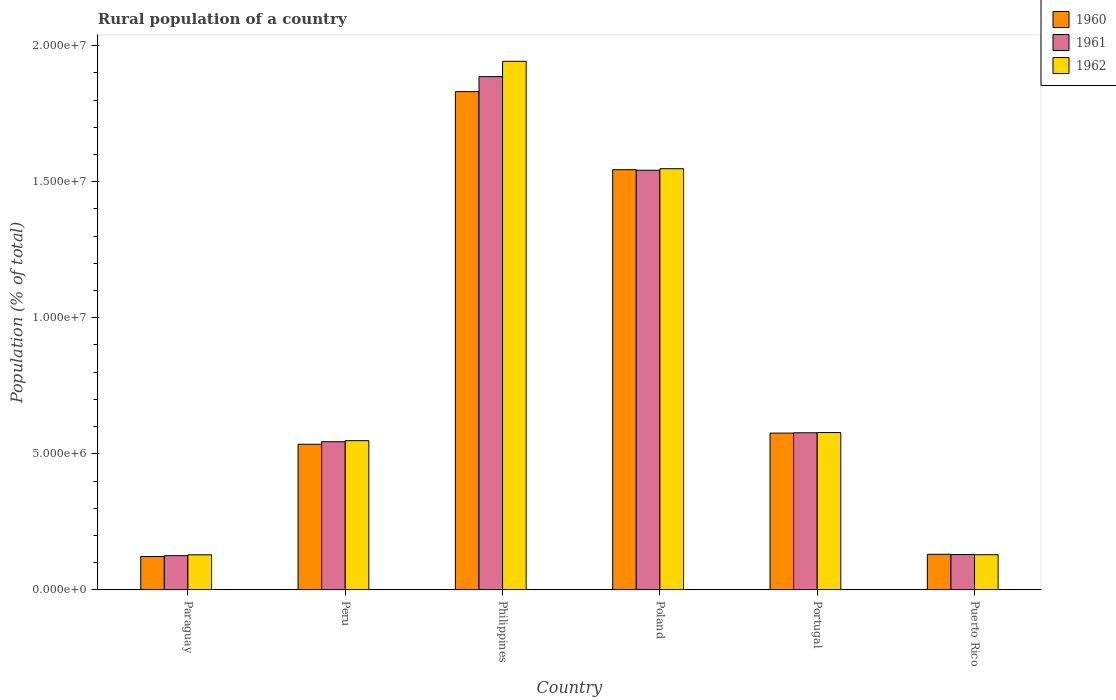How many different coloured bars are there?
Your answer should be compact. 3. How many groups of bars are there?
Your answer should be very brief. 6. What is the label of the 5th group of bars from the left?
Your answer should be very brief. Portugal. In how many cases, is the number of bars for a given country not equal to the number of legend labels?
Provide a succinct answer. 0. What is the rural population in 1961 in Paraguay?
Give a very brief answer. 1.26e+06. Across all countries, what is the maximum rural population in 1962?
Provide a short and direct response. 1.94e+07. Across all countries, what is the minimum rural population in 1960?
Your response must be concise. 1.23e+06. In which country was the rural population in 1961 maximum?
Provide a succinct answer. Philippines. In which country was the rural population in 1962 minimum?
Provide a short and direct response. Paraguay. What is the total rural population in 1962 in the graph?
Make the answer very short. 4.88e+07. What is the difference between the rural population in 1960 in Paraguay and that in Puerto Rico?
Provide a short and direct response. -8.15e+04. What is the difference between the rural population in 1961 in Philippines and the rural population in 1962 in Peru?
Your answer should be very brief. 1.34e+07. What is the average rural population in 1961 per country?
Your answer should be compact. 8.01e+06. What is the difference between the rural population of/in 1962 and rural population of/in 1960 in Philippines?
Provide a short and direct response. 1.11e+06. What is the ratio of the rural population in 1962 in Paraguay to that in Poland?
Offer a terse response. 0.08. Is the rural population in 1962 in Poland less than that in Puerto Rico?
Make the answer very short. No. Is the difference between the rural population in 1962 in Portugal and Puerto Rico greater than the difference between the rural population in 1960 in Portugal and Puerto Rico?
Ensure brevity in your answer.  Yes. What is the difference between the highest and the second highest rural population in 1960?
Provide a short and direct response. -9.68e+06. What is the difference between the highest and the lowest rural population in 1961?
Make the answer very short. 1.76e+07. In how many countries, is the rural population in 1961 greater than the average rural population in 1961 taken over all countries?
Your response must be concise. 2. Is the sum of the rural population in 1962 in Peru and Portugal greater than the maximum rural population in 1960 across all countries?
Your answer should be compact. No. What does the 2nd bar from the left in Paraguay represents?
Your answer should be very brief. 1961. Is it the case that in every country, the sum of the rural population in 1962 and rural population in 1961 is greater than the rural population in 1960?
Provide a succinct answer. Yes. How many bars are there?
Make the answer very short. 18. Are all the bars in the graph horizontal?
Keep it short and to the point. No. How many countries are there in the graph?
Your response must be concise. 6. What is the difference between two consecutive major ticks on the Y-axis?
Your response must be concise. 5.00e+06. Does the graph contain any zero values?
Your response must be concise. No. Does the graph contain grids?
Make the answer very short. No. How many legend labels are there?
Ensure brevity in your answer.  3. What is the title of the graph?
Your answer should be very brief. Rural population of a country. What is the label or title of the Y-axis?
Your answer should be very brief. Population (% of total). What is the Population (% of total) in 1960 in Paraguay?
Make the answer very short. 1.23e+06. What is the Population (% of total) of 1961 in Paraguay?
Offer a terse response. 1.26e+06. What is the Population (% of total) in 1962 in Paraguay?
Make the answer very short. 1.29e+06. What is the Population (% of total) in 1960 in Peru?
Ensure brevity in your answer.  5.35e+06. What is the Population (% of total) in 1961 in Peru?
Keep it short and to the point. 5.44e+06. What is the Population (% of total) of 1962 in Peru?
Give a very brief answer. 5.48e+06. What is the Population (% of total) of 1960 in Philippines?
Offer a terse response. 1.83e+07. What is the Population (% of total) in 1961 in Philippines?
Ensure brevity in your answer.  1.89e+07. What is the Population (% of total) in 1962 in Philippines?
Provide a succinct answer. 1.94e+07. What is the Population (% of total) of 1960 in Poland?
Make the answer very short. 1.54e+07. What is the Population (% of total) of 1961 in Poland?
Give a very brief answer. 1.54e+07. What is the Population (% of total) in 1962 in Poland?
Your answer should be compact. 1.55e+07. What is the Population (% of total) of 1960 in Portugal?
Your response must be concise. 5.76e+06. What is the Population (% of total) in 1961 in Portugal?
Provide a short and direct response. 5.77e+06. What is the Population (% of total) in 1962 in Portugal?
Give a very brief answer. 5.78e+06. What is the Population (% of total) of 1960 in Puerto Rico?
Your answer should be very brief. 1.31e+06. What is the Population (% of total) in 1961 in Puerto Rico?
Make the answer very short. 1.30e+06. What is the Population (% of total) in 1962 in Puerto Rico?
Give a very brief answer. 1.29e+06. Across all countries, what is the maximum Population (% of total) in 1960?
Your response must be concise. 1.83e+07. Across all countries, what is the maximum Population (% of total) in 1961?
Keep it short and to the point. 1.89e+07. Across all countries, what is the maximum Population (% of total) in 1962?
Provide a succinct answer. 1.94e+07. Across all countries, what is the minimum Population (% of total) in 1960?
Keep it short and to the point. 1.23e+06. Across all countries, what is the minimum Population (% of total) in 1961?
Keep it short and to the point. 1.26e+06. Across all countries, what is the minimum Population (% of total) in 1962?
Your response must be concise. 1.29e+06. What is the total Population (% of total) in 1960 in the graph?
Offer a terse response. 4.74e+07. What is the total Population (% of total) in 1961 in the graph?
Provide a succinct answer. 4.81e+07. What is the total Population (% of total) in 1962 in the graph?
Keep it short and to the point. 4.88e+07. What is the difference between the Population (% of total) of 1960 in Paraguay and that in Peru?
Give a very brief answer. -4.13e+06. What is the difference between the Population (% of total) of 1961 in Paraguay and that in Peru?
Your answer should be very brief. -4.19e+06. What is the difference between the Population (% of total) in 1962 in Paraguay and that in Peru?
Ensure brevity in your answer.  -4.20e+06. What is the difference between the Population (% of total) in 1960 in Paraguay and that in Philippines?
Offer a terse response. -1.71e+07. What is the difference between the Population (% of total) of 1961 in Paraguay and that in Philippines?
Give a very brief answer. -1.76e+07. What is the difference between the Population (% of total) in 1962 in Paraguay and that in Philippines?
Keep it short and to the point. -1.81e+07. What is the difference between the Population (% of total) in 1960 in Paraguay and that in Poland?
Keep it short and to the point. -1.42e+07. What is the difference between the Population (% of total) in 1961 in Paraguay and that in Poland?
Provide a succinct answer. -1.42e+07. What is the difference between the Population (% of total) of 1962 in Paraguay and that in Poland?
Your answer should be very brief. -1.42e+07. What is the difference between the Population (% of total) of 1960 in Paraguay and that in Portugal?
Ensure brevity in your answer.  -4.54e+06. What is the difference between the Population (% of total) in 1961 in Paraguay and that in Portugal?
Provide a short and direct response. -4.52e+06. What is the difference between the Population (% of total) in 1962 in Paraguay and that in Portugal?
Your answer should be compact. -4.49e+06. What is the difference between the Population (% of total) in 1960 in Paraguay and that in Puerto Rico?
Offer a terse response. -8.15e+04. What is the difference between the Population (% of total) of 1961 in Paraguay and that in Puerto Rico?
Make the answer very short. -4.09e+04. What is the difference between the Population (% of total) of 1962 in Paraguay and that in Puerto Rico?
Offer a terse response. -2650. What is the difference between the Population (% of total) of 1960 in Peru and that in Philippines?
Provide a short and direct response. -1.30e+07. What is the difference between the Population (% of total) of 1961 in Peru and that in Philippines?
Your answer should be compact. -1.34e+07. What is the difference between the Population (% of total) in 1962 in Peru and that in Philippines?
Ensure brevity in your answer.  -1.39e+07. What is the difference between the Population (% of total) in 1960 in Peru and that in Poland?
Offer a very short reply. -1.01e+07. What is the difference between the Population (% of total) of 1961 in Peru and that in Poland?
Give a very brief answer. -9.98e+06. What is the difference between the Population (% of total) in 1962 in Peru and that in Poland?
Provide a succinct answer. -1.00e+07. What is the difference between the Population (% of total) in 1960 in Peru and that in Portugal?
Your answer should be compact. -4.10e+05. What is the difference between the Population (% of total) in 1961 in Peru and that in Portugal?
Provide a succinct answer. -3.29e+05. What is the difference between the Population (% of total) in 1962 in Peru and that in Portugal?
Your answer should be compact. -2.98e+05. What is the difference between the Population (% of total) of 1960 in Peru and that in Puerto Rico?
Offer a very short reply. 4.04e+06. What is the difference between the Population (% of total) in 1961 in Peru and that in Puerto Rico?
Keep it short and to the point. 4.15e+06. What is the difference between the Population (% of total) of 1962 in Peru and that in Puerto Rico?
Provide a succinct answer. 4.19e+06. What is the difference between the Population (% of total) in 1960 in Philippines and that in Poland?
Ensure brevity in your answer.  2.87e+06. What is the difference between the Population (% of total) in 1961 in Philippines and that in Poland?
Your answer should be compact. 3.44e+06. What is the difference between the Population (% of total) in 1962 in Philippines and that in Poland?
Make the answer very short. 3.95e+06. What is the difference between the Population (% of total) in 1960 in Philippines and that in Portugal?
Your response must be concise. 1.26e+07. What is the difference between the Population (% of total) of 1961 in Philippines and that in Portugal?
Ensure brevity in your answer.  1.31e+07. What is the difference between the Population (% of total) in 1962 in Philippines and that in Portugal?
Keep it short and to the point. 1.36e+07. What is the difference between the Population (% of total) in 1960 in Philippines and that in Puerto Rico?
Make the answer very short. 1.70e+07. What is the difference between the Population (% of total) of 1961 in Philippines and that in Puerto Rico?
Your answer should be very brief. 1.76e+07. What is the difference between the Population (% of total) in 1962 in Philippines and that in Puerto Rico?
Give a very brief answer. 1.81e+07. What is the difference between the Population (% of total) of 1960 in Poland and that in Portugal?
Offer a very short reply. 9.68e+06. What is the difference between the Population (% of total) in 1961 in Poland and that in Portugal?
Make the answer very short. 9.65e+06. What is the difference between the Population (% of total) of 1962 in Poland and that in Portugal?
Make the answer very short. 9.70e+06. What is the difference between the Population (% of total) of 1960 in Poland and that in Puerto Rico?
Keep it short and to the point. 1.41e+07. What is the difference between the Population (% of total) of 1961 in Poland and that in Puerto Rico?
Provide a short and direct response. 1.41e+07. What is the difference between the Population (% of total) in 1962 in Poland and that in Puerto Rico?
Make the answer very short. 1.42e+07. What is the difference between the Population (% of total) in 1960 in Portugal and that in Puerto Rico?
Make the answer very short. 4.45e+06. What is the difference between the Population (% of total) in 1961 in Portugal and that in Puerto Rico?
Offer a very short reply. 4.48e+06. What is the difference between the Population (% of total) of 1962 in Portugal and that in Puerto Rico?
Keep it short and to the point. 4.49e+06. What is the difference between the Population (% of total) in 1960 in Paraguay and the Population (% of total) in 1961 in Peru?
Your answer should be compact. -4.22e+06. What is the difference between the Population (% of total) of 1960 in Paraguay and the Population (% of total) of 1962 in Peru?
Provide a succinct answer. -4.26e+06. What is the difference between the Population (% of total) in 1961 in Paraguay and the Population (% of total) in 1962 in Peru?
Offer a terse response. -4.23e+06. What is the difference between the Population (% of total) of 1960 in Paraguay and the Population (% of total) of 1961 in Philippines?
Your response must be concise. -1.76e+07. What is the difference between the Population (% of total) of 1960 in Paraguay and the Population (% of total) of 1962 in Philippines?
Keep it short and to the point. -1.82e+07. What is the difference between the Population (% of total) in 1961 in Paraguay and the Population (% of total) in 1962 in Philippines?
Your answer should be very brief. -1.82e+07. What is the difference between the Population (% of total) in 1960 in Paraguay and the Population (% of total) in 1961 in Poland?
Your response must be concise. -1.42e+07. What is the difference between the Population (% of total) of 1960 in Paraguay and the Population (% of total) of 1962 in Poland?
Your response must be concise. -1.43e+07. What is the difference between the Population (% of total) in 1961 in Paraguay and the Population (% of total) in 1962 in Poland?
Give a very brief answer. -1.42e+07. What is the difference between the Population (% of total) of 1960 in Paraguay and the Population (% of total) of 1961 in Portugal?
Your answer should be very brief. -4.55e+06. What is the difference between the Population (% of total) of 1960 in Paraguay and the Population (% of total) of 1962 in Portugal?
Your response must be concise. -4.56e+06. What is the difference between the Population (% of total) in 1961 in Paraguay and the Population (% of total) in 1962 in Portugal?
Offer a terse response. -4.52e+06. What is the difference between the Population (% of total) in 1960 in Paraguay and the Population (% of total) in 1961 in Puerto Rico?
Provide a succinct answer. -7.14e+04. What is the difference between the Population (% of total) in 1960 in Paraguay and the Population (% of total) in 1962 in Puerto Rico?
Your answer should be compact. -6.46e+04. What is the difference between the Population (% of total) of 1961 in Paraguay and the Population (% of total) of 1962 in Puerto Rico?
Give a very brief answer. -3.41e+04. What is the difference between the Population (% of total) in 1960 in Peru and the Population (% of total) in 1961 in Philippines?
Provide a short and direct response. -1.35e+07. What is the difference between the Population (% of total) in 1960 in Peru and the Population (% of total) in 1962 in Philippines?
Your answer should be very brief. -1.41e+07. What is the difference between the Population (% of total) of 1961 in Peru and the Population (% of total) of 1962 in Philippines?
Provide a succinct answer. -1.40e+07. What is the difference between the Population (% of total) in 1960 in Peru and the Population (% of total) in 1961 in Poland?
Your response must be concise. -1.01e+07. What is the difference between the Population (% of total) in 1960 in Peru and the Population (% of total) in 1962 in Poland?
Make the answer very short. -1.01e+07. What is the difference between the Population (% of total) of 1961 in Peru and the Population (% of total) of 1962 in Poland?
Your answer should be very brief. -1.00e+07. What is the difference between the Population (% of total) of 1960 in Peru and the Population (% of total) of 1961 in Portugal?
Make the answer very short. -4.22e+05. What is the difference between the Population (% of total) in 1960 in Peru and the Population (% of total) in 1962 in Portugal?
Your answer should be compact. -4.30e+05. What is the difference between the Population (% of total) of 1961 in Peru and the Population (% of total) of 1962 in Portugal?
Your answer should be very brief. -3.37e+05. What is the difference between the Population (% of total) in 1960 in Peru and the Population (% of total) in 1961 in Puerto Rico?
Offer a very short reply. 4.05e+06. What is the difference between the Population (% of total) of 1960 in Peru and the Population (% of total) of 1962 in Puerto Rico?
Make the answer very short. 4.06e+06. What is the difference between the Population (% of total) of 1961 in Peru and the Population (% of total) of 1962 in Puerto Rico?
Offer a very short reply. 4.15e+06. What is the difference between the Population (% of total) in 1960 in Philippines and the Population (% of total) in 1961 in Poland?
Offer a terse response. 2.89e+06. What is the difference between the Population (% of total) of 1960 in Philippines and the Population (% of total) of 1962 in Poland?
Your answer should be compact. 2.83e+06. What is the difference between the Population (% of total) in 1961 in Philippines and the Population (% of total) in 1962 in Poland?
Keep it short and to the point. 3.38e+06. What is the difference between the Population (% of total) in 1960 in Philippines and the Population (% of total) in 1961 in Portugal?
Offer a terse response. 1.25e+07. What is the difference between the Population (% of total) in 1960 in Philippines and the Population (% of total) in 1962 in Portugal?
Offer a terse response. 1.25e+07. What is the difference between the Population (% of total) of 1961 in Philippines and the Population (% of total) of 1962 in Portugal?
Your response must be concise. 1.31e+07. What is the difference between the Population (% of total) in 1960 in Philippines and the Population (% of total) in 1961 in Puerto Rico?
Keep it short and to the point. 1.70e+07. What is the difference between the Population (% of total) in 1960 in Philippines and the Population (% of total) in 1962 in Puerto Rico?
Offer a very short reply. 1.70e+07. What is the difference between the Population (% of total) of 1961 in Philippines and the Population (% of total) of 1962 in Puerto Rico?
Keep it short and to the point. 1.76e+07. What is the difference between the Population (% of total) of 1960 in Poland and the Population (% of total) of 1961 in Portugal?
Your answer should be very brief. 9.67e+06. What is the difference between the Population (% of total) of 1960 in Poland and the Population (% of total) of 1962 in Portugal?
Give a very brief answer. 9.66e+06. What is the difference between the Population (% of total) of 1961 in Poland and the Population (% of total) of 1962 in Portugal?
Provide a succinct answer. 9.64e+06. What is the difference between the Population (% of total) in 1960 in Poland and the Population (% of total) in 1961 in Puerto Rico?
Give a very brief answer. 1.41e+07. What is the difference between the Population (% of total) of 1960 in Poland and the Population (% of total) of 1962 in Puerto Rico?
Your answer should be compact. 1.42e+07. What is the difference between the Population (% of total) of 1961 in Poland and the Population (% of total) of 1962 in Puerto Rico?
Offer a terse response. 1.41e+07. What is the difference between the Population (% of total) of 1960 in Portugal and the Population (% of total) of 1961 in Puerto Rico?
Provide a short and direct response. 4.46e+06. What is the difference between the Population (% of total) in 1960 in Portugal and the Population (% of total) in 1962 in Puerto Rico?
Your response must be concise. 4.47e+06. What is the difference between the Population (% of total) in 1961 in Portugal and the Population (% of total) in 1962 in Puerto Rico?
Ensure brevity in your answer.  4.48e+06. What is the average Population (% of total) of 1960 per country?
Ensure brevity in your answer.  7.90e+06. What is the average Population (% of total) of 1961 per country?
Give a very brief answer. 8.01e+06. What is the average Population (% of total) in 1962 per country?
Offer a very short reply. 8.13e+06. What is the difference between the Population (% of total) of 1960 and Population (% of total) of 1961 in Paraguay?
Your response must be concise. -3.05e+04. What is the difference between the Population (% of total) of 1960 and Population (% of total) of 1962 in Paraguay?
Your answer should be very brief. -6.20e+04. What is the difference between the Population (% of total) of 1961 and Population (% of total) of 1962 in Paraguay?
Make the answer very short. -3.14e+04. What is the difference between the Population (% of total) of 1960 and Population (% of total) of 1961 in Peru?
Your response must be concise. -9.28e+04. What is the difference between the Population (% of total) in 1960 and Population (% of total) in 1962 in Peru?
Provide a short and direct response. -1.32e+05. What is the difference between the Population (% of total) in 1961 and Population (% of total) in 1962 in Peru?
Give a very brief answer. -3.92e+04. What is the difference between the Population (% of total) of 1960 and Population (% of total) of 1961 in Philippines?
Your answer should be compact. -5.51e+05. What is the difference between the Population (% of total) in 1960 and Population (% of total) in 1962 in Philippines?
Your response must be concise. -1.11e+06. What is the difference between the Population (% of total) of 1961 and Population (% of total) of 1962 in Philippines?
Your answer should be compact. -5.63e+05. What is the difference between the Population (% of total) in 1960 and Population (% of total) in 1961 in Poland?
Make the answer very short. 2.01e+04. What is the difference between the Population (% of total) in 1960 and Population (% of total) in 1962 in Poland?
Offer a terse response. -3.63e+04. What is the difference between the Population (% of total) of 1961 and Population (% of total) of 1962 in Poland?
Keep it short and to the point. -5.64e+04. What is the difference between the Population (% of total) in 1960 and Population (% of total) in 1961 in Portugal?
Provide a short and direct response. -1.18e+04. What is the difference between the Population (% of total) in 1960 and Population (% of total) in 1962 in Portugal?
Make the answer very short. -1.97e+04. What is the difference between the Population (% of total) in 1961 and Population (% of total) in 1962 in Portugal?
Ensure brevity in your answer.  -7815. What is the difference between the Population (% of total) in 1960 and Population (% of total) in 1961 in Puerto Rico?
Keep it short and to the point. 1.01e+04. What is the difference between the Population (% of total) in 1960 and Population (% of total) in 1962 in Puerto Rico?
Keep it short and to the point. 1.69e+04. What is the difference between the Population (% of total) in 1961 and Population (% of total) in 1962 in Puerto Rico?
Provide a succinct answer. 6800. What is the ratio of the Population (% of total) in 1960 in Paraguay to that in Peru?
Your answer should be compact. 0.23. What is the ratio of the Population (% of total) in 1961 in Paraguay to that in Peru?
Keep it short and to the point. 0.23. What is the ratio of the Population (% of total) of 1962 in Paraguay to that in Peru?
Your answer should be very brief. 0.23. What is the ratio of the Population (% of total) of 1960 in Paraguay to that in Philippines?
Make the answer very short. 0.07. What is the ratio of the Population (% of total) of 1961 in Paraguay to that in Philippines?
Offer a very short reply. 0.07. What is the ratio of the Population (% of total) in 1962 in Paraguay to that in Philippines?
Provide a short and direct response. 0.07. What is the ratio of the Population (% of total) of 1960 in Paraguay to that in Poland?
Your answer should be compact. 0.08. What is the ratio of the Population (% of total) of 1961 in Paraguay to that in Poland?
Ensure brevity in your answer.  0.08. What is the ratio of the Population (% of total) in 1962 in Paraguay to that in Poland?
Your response must be concise. 0.08. What is the ratio of the Population (% of total) of 1960 in Paraguay to that in Portugal?
Give a very brief answer. 0.21. What is the ratio of the Population (% of total) of 1961 in Paraguay to that in Portugal?
Your answer should be very brief. 0.22. What is the ratio of the Population (% of total) of 1962 in Paraguay to that in Portugal?
Your response must be concise. 0.22. What is the ratio of the Population (% of total) in 1960 in Paraguay to that in Puerto Rico?
Ensure brevity in your answer.  0.94. What is the ratio of the Population (% of total) in 1961 in Paraguay to that in Puerto Rico?
Ensure brevity in your answer.  0.97. What is the ratio of the Population (% of total) in 1960 in Peru to that in Philippines?
Offer a terse response. 0.29. What is the ratio of the Population (% of total) in 1961 in Peru to that in Philippines?
Provide a succinct answer. 0.29. What is the ratio of the Population (% of total) of 1962 in Peru to that in Philippines?
Your answer should be compact. 0.28. What is the ratio of the Population (% of total) of 1960 in Peru to that in Poland?
Give a very brief answer. 0.35. What is the ratio of the Population (% of total) of 1961 in Peru to that in Poland?
Make the answer very short. 0.35. What is the ratio of the Population (% of total) of 1962 in Peru to that in Poland?
Provide a short and direct response. 0.35. What is the ratio of the Population (% of total) of 1960 in Peru to that in Portugal?
Your answer should be very brief. 0.93. What is the ratio of the Population (% of total) of 1961 in Peru to that in Portugal?
Keep it short and to the point. 0.94. What is the ratio of the Population (% of total) in 1962 in Peru to that in Portugal?
Your response must be concise. 0.95. What is the ratio of the Population (% of total) in 1960 in Peru to that in Puerto Rico?
Offer a very short reply. 4.09. What is the ratio of the Population (% of total) of 1961 in Peru to that in Puerto Rico?
Ensure brevity in your answer.  4.2. What is the ratio of the Population (% of total) of 1962 in Peru to that in Puerto Rico?
Offer a very short reply. 4.25. What is the ratio of the Population (% of total) in 1960 in Philippines to that in Poland?
Your answer should be very brief. 1.19. What is the ratio of the Population (% of total) in 1961 in Philippines to that in Poland?
Offer a terse response. 1.22. What is the ratio of the Population (% of total) of 1962 in Philippines to that in Poland?
Give a very brief answer. 1.25. What is the ratio of the Population (% of total) in 1960 in Philippines to that in Portugal?
Give a very brief answer. 3.18. What is the ratio of the Population (% of total) in 1961 in Philippines to that in Portugal?
Your response must be concise. 3.27. What is the ratio of the Population (% of total) in 1962 in Philippines to that in Portugal?
Offer a terse response. 3.36. What is the ratio of the Population (% of total) in 1960 in Philippines to that in Puerto Rico?
Your answer should be compact. 14.01. What is the ratio of the Population (% of total) in 1961 in Philippines to that in Puerto Rico?
Ensure brevity in your answer.  14.54. What is the ratio of the Population (% of total) of 1962 in Philippines to that in Puerto Rico?
Provide a short and direct response. 15.05. What is the ratio of the Population (% of total) in 1960 in Poland to that in Portugal?
Keep it short and to the point. 2.68. What is the ratio of the Population (% of total) in 1961 in Poland to that in Portugal?
Your answer should be very brief. 2.67. What is the ratio of the Population (% of total) in 1962 in Poland to that in Portugal?
Offer a terse response. 2.68. What is the ratio of the Population (% of total) in 1960 in Poland to that in Puerto Rico?
Make the answer very short. 11.81. What is the ratio of the Population (% of total) of 1961 in Poland to that in Puerto Rico?
Give a very brief answer. 11.89. What is the ratio of the Population (% of total) of 1962 in Poland to that in Puerto Rico?
Provide a short and direct response. 11.99. What is the ratio of the Population (% of total) of 1960 in Portugal to that in Puerto Rico?
Offer a very short reply. 4.41. What is the ratio of the Population (% of total) of 1961 in Portugal to that in Puerto Rico?
Make the answer very short. 4.45. What is the ratio of the Population (% of total) in 1962 in Portugal to that in Puerto Rico?
Provide a short and direct response. 4.48. What is the difference between the highest and the second highest Population (% of total) of 1960?
Provide a short and direct response. 2.87e+06. What is the difference between the highest and the second highest Population (% of total) in 1961?
Offer a terse response. 3.44e+06. What is the difference between the highest and the second highest Population (% of total) in 1962?
Make the answer very short. 3.95e+06. What is the difference between the highest and the lowest Population (% of total) in 1960?
Make the answer very short. 1.71e+07. What is the difference between the highest and the lowest Population (% of total) of 1961?
Your response must be concise. 1.76e+07. What is the difference between the highest and the lowest Population (% of total) of 1962?
Offer a very short reply. 1.81e+07. 